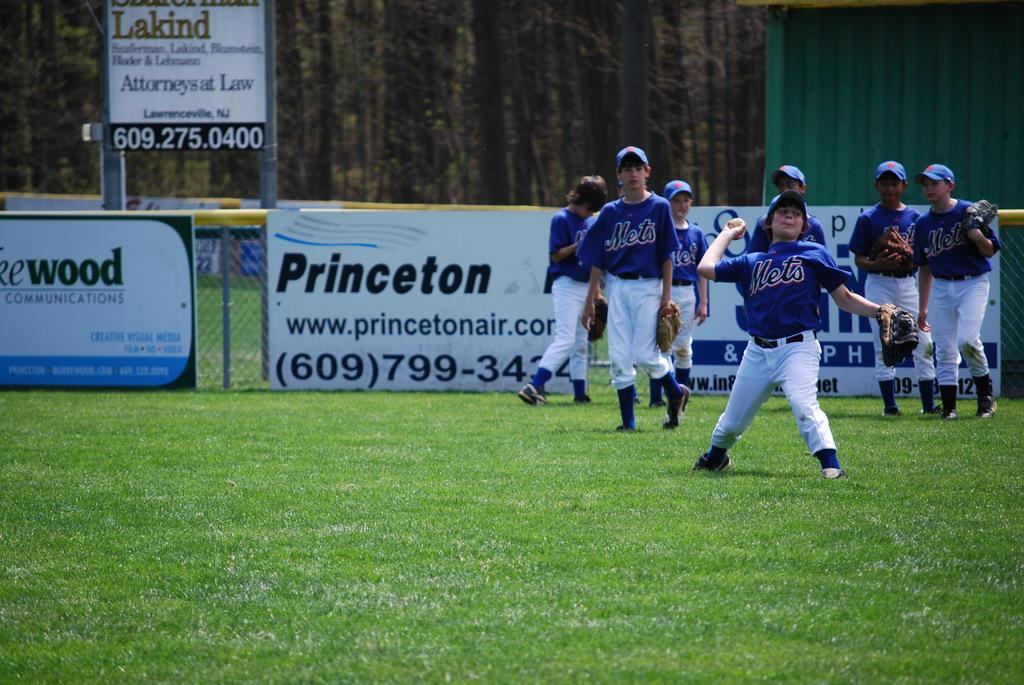<image>
Write a terse but informative summary of the picture. A kid's baseball team is wearing Mets jerseys on field. 